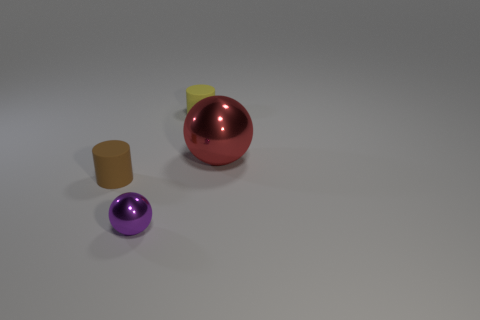Is the number of tiny purple metal spheres that are behind the tiny yellow cylinder the same as the number of purple shiny balls to the right of the purple shiny object?
Keep it short and to the point. Yes. There is a thing on the right side of the small rubber object right of the tiny brown matte object; what is its material?
Offer a terse response. Metal. How many things are purple things or rubber cylinders?
Your answer should be very brief. 3. Are there fewer cylinders than small red matte balls?
Give a very brief answer. No. What is the size of the red object that is the same material as the purple object?
Provide a succinct answer. Large. What is the size of the red sphere?
Ensure brevity in your answer.  Large. There is a tiny purple object; what shape is it?
Your answer should be compact. Sphere. The other metallic thing that is the same shape as the tiny metallic object is what size?
Offer a very short reply. Large. There is a sphere that is on the right side of the tiny cylinder right of the brown object; is there a tiny yellow rubber cylinder that is in front of it?
Provide a short and direct response. No. What material is the cylinder behind the red metallic ball?
Provide a short and direct response. Rubber. 